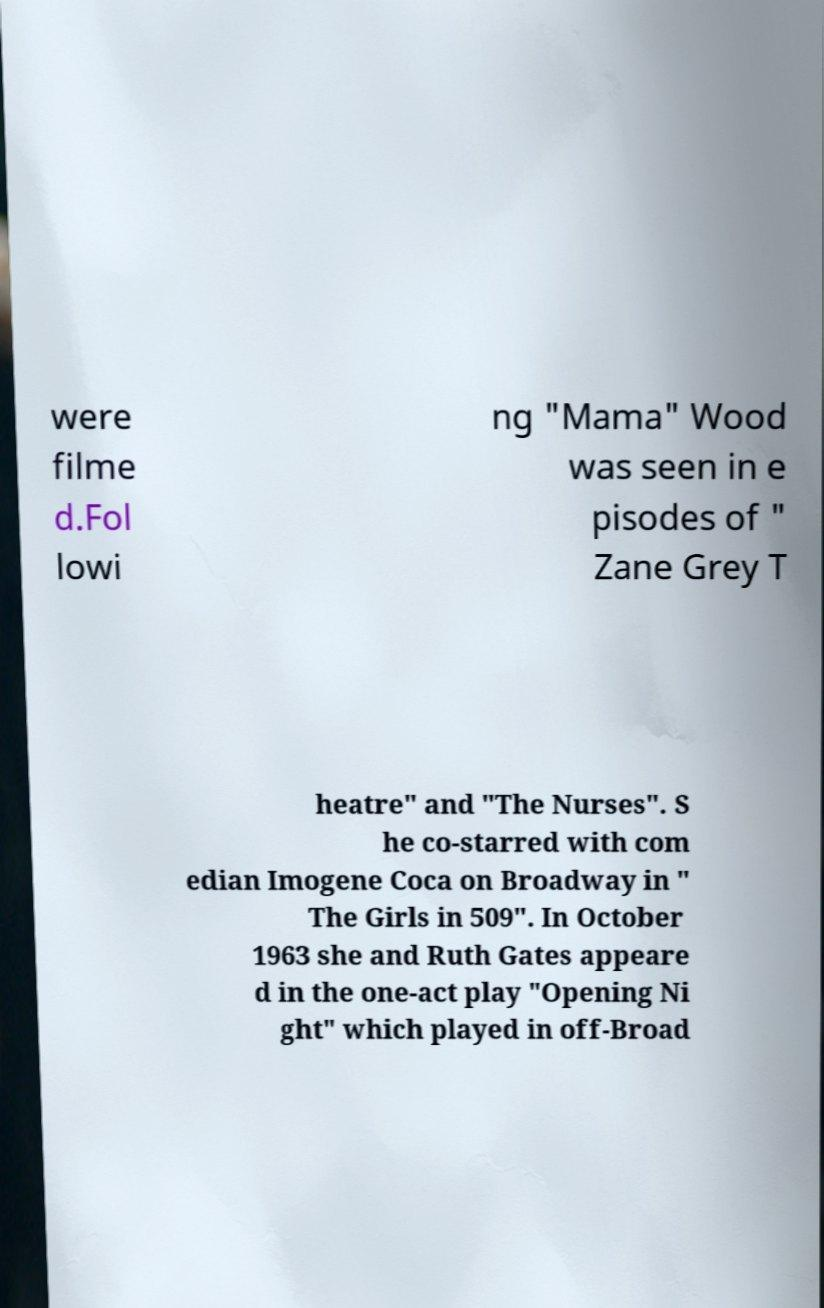I need the written content from this picture converted into text. Can you do that? were filme d.Fol lowi ng "Mama" Wood was seen in e pisodes of " Zane Grey T heatre" and "The Nurses". S he co-starred with com edian Imogene Coca on Broadway in " The Girls in 509". In October 1963 she and Ruth Gates appeare d in the one-act play "Opening Ni ght" which played in off-Broad 